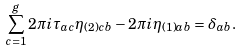<formula> <loc_0><loc_0><loc_500><loc_500>\sum _ { c = 1 } ^ { g } 2 \pi i \tau _ { a c } \eta _ { ( 2 ) c b } - 2 \pi i \eta _ { ( 1 ) a b } = \delta _ { a b } .</formula> 